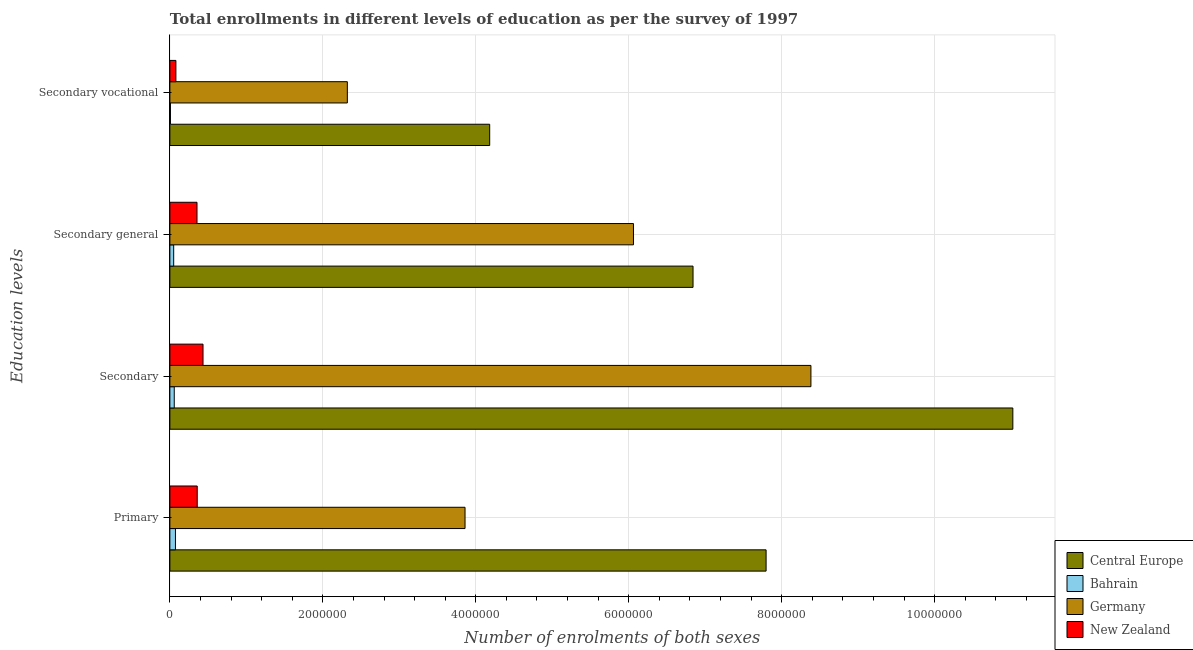How many different coloured bars are there?
Keep it short and to the point. 4. Are the number of bars per tick equal to the number of legend labels?
Offer a terse response. Yes. How many bars are there on the 3rd tick from the top?
Your answer should be very brief. 4. How many bars are there on the 4th tick from the bottom?
Your answer should be very brief. 4. What is the label of the 3rd group of bars from the top?
Your answer should be very brief. Secondary. What is the number of enrolments in secondary vocational education in Germany?
Provide a succinct answer. 2.32e+06. Across all countries, what is the maximum number of enrolments in secondary general education?
Your response must be concise. 6.84e+06. Across all countries, what is the minimum number of enrolments in primary education?
Your answer should be very brief. 7.29e+04. In which country was the number of enrolments in primary education maximum?
Give a very brief answer. Central Europe. In which country was the number of enrolments in secondary general education minimum?
Offer a very short reply. Bahrain. What is the total number of enrolments in secondary vocational education in the graph?
Offer a terse response. 6.59e+06. What is the difference between the number of enrolments in secondary vocational education in Germany and that in Bahrain?
Offer a very short reply. 2.31e+06. What is the difference between the number of enrolments in primary education in Bahrain and the number of enrolments in secondary education in New Zealand?
Your answer should be very brief. -3.60e+05. What is the average number of enrolments in primary education per country?
Offer a terse response. 3.02e+06. What is the difference between the number of enrolments in secondary education and number of enrolments in secondary vocational education in Bahrain?
Provide a succinct answer. 4.99e+04. What is the ratio of the number of enrolments in secondary vocational education in New Zealand to that in Germany?
Ensure brevity in your answer.  0.03. Is the difference between the number of enrolments in secondary vocational education in New Zealand and Central Europe greater than the difference between the number of enrolments in secondary education in New Zealand and Central Europe?
Provide a succinct answer. Yes. What is the difference between the highest and the second highest number of enrolments in primary education?
Your answer should be compact. 3.94e+06. What is the difference between the highest and the lowest number of enrolments in primary education?
Offer a very short reply. 7.72e+06. In how many countries, is the number of enrolments in secondary general education greater than the average number of enrolments in secondary general education taken over all countries?
Give a very brief answer. 2. What does the 4th bar from the top in Secondary general represents?
Provide a short and direct response. Central Europe. How many bars are there?
Make the answer very short. 16. Are all the bars in the graph horizontal?
Offer a terse response. Yes. How many countries are there in the graph?
Provide a succinct answer. 4. What is the difference between two consecutive major ticks on the X-axis?
Offer a terse response. 2.00e+06. How are the legend labels stacked?
Keep it short and to the point. Vertical. What is the title of the graph?
Keep it short and to the point. Total enrollments in different levels of education as per the survey of 1997. What is the label or title of the X-axis?
Make the answer very short. Number of enrolments of both sexes. What is the label or title of the Y-axis?
Offer a terse response. Education levels. What is the Number of enrolments of both sexes of Central Europe in Primary?
Offer a very short reply. 7.80e+06. What is the Number of enrolments of both sexes of Bahrain in Primary?
Your answer should be compact. 7.29e+04. What is the Number of enrolments of both sexes in Germany in Primary?
Provide a succinct answer. 3.86e+06. What is the Number of enrolments of both sexes in New Zealand in Primary?
Provide a short and direct response. 3.58e+05. What is the Number of enrolments of both sexes of Central Europe in Secondary?
Make the answer very short. 1.10e+07. What is the Number of enrolments of both sexes of Bahrain in Secondary?
Offer a very short reply. 5.72e+04. What is the Number of enrolments of both sexes in Germany in Secondary?
Provide a short and direct response. 8.38e+06. What is the Number of enrolments of both sexes in New Zealand in Secondary?
Provide a short and direct response. 4.33e+05. What is the Number of enrolments of both sexes of Central Europe in Secondary general?
Offer a very short reply. 6.84e+06. What is the Number of enrolments of both sexes of Bahrain in Secondary general?
Ensure brevity in your answer.  4.99e+04. What is the Number of enrolments of both sexes of Germany in Secondary general?
Your answer should be compact. 6.06e+06. What is the Number of enrolments of both sexes of New Zealand in Secondary general?
Your response must be concise. 3.55e+05. What is the Number of enrolments of both sexes of Central Europe in Secondary vocational?
Your response must be concise. 4.18e+06. What is the Number of enrolments of both sexes in Bahrain in Secondary vocational?
Provide a succinct answer. 7287. What is the Number of enrolments of both sexes in Germany in Secondary vocational?
Provide a short and direct response. 2.32e+06. What is the Number of enrolments of both sexes of New Zealand in Secondary vocational?
Keep it short and to the point. 7.86e+04. Across all Education levels, what is the maximum Number of enrolments of both sexes in Central Europe?
Keep it short and to the point. 1.10e+07. Across all Education levels, what is the maximum Number of enrolments of both sexes of Bahrain?
Your answer should be very brief. 7.29e+04. Across all Education levels, what is the maximum Number of enrolments of both sexes of Germany?
Make the answer very short. 8.38e+06. Across all Education levels, what is the maximum Number of enrolments of both sexes of New Zealand?
Provide a short and direct response. 4.33e+05. Across all Education levels, what is the minimum Number of enrolments of both sexes in Central Europe?
Provide a succinct answer. 4.18e+06. Across all Education levels, what is the minimum Number of enrolments of both sexes in Bahrain?
Give a very brief answer. 7287. Across all Education levels, what is the minimum Number of enrolments of both sexes of Germany?
Your answer should be compact. 2.32e+06. Across all Education levels, what is the minimum Number of enrolments of both sexes of New Zealand?
Provide a succinct answer. 7.86e+04. What is the total Number of enrolments of both sexes of Central Europe in the graph?
Give a very brief answer. 2.98e+07. What is the total Number of enrolments of both sexes of Bahrain in the graph?
Your response must be concise. 1.87e+05. What is the total Number of enrolments of both sexes in Germany in the graph?
Keep it short and to the point. 2.06e+07. What is the total Number of enrolments of both sexes in New Zealand in the graph?
Your answer should be very brief. 1.22e+06. What is the difference between the Number of enrolments of both sexes of Central Europe in Primary and that in Secondary?
Ensure brevity in your answer.  -3.23e+06. What is the difference between the Number of enrolments of both sexes of Bahrain in Primary and that in Secondary?
Make the answer very short. 1.57e+04. What is the difference between the Number of enrolments of both sexes of Germany in Primary and that in Secondary?
Provide a succinct answer. -4.52e+06. What is the difference between the Number of enrolments of both sexes of New Zealand in Primary and that in Secondary?
Your answer should be very brief. -7.58e+04. What is the difference between the Number of enrolments of both sexes in Central Europe in Primary and that in Secondary general?
Your answer should be very brief. 9.55e+05. What is the difference between the Number of enrolments of both sexes of Bahrain in Primary and that in Secondary general?
Keep it short and to the point. 2.30e+04. What is the difference between the Number of enrolments of both sexes in Germany in Primary and that in Secondary general?
Provide a short and direct response. -2.20e+06. What is the difference between the Number of enrolments of both sexes of New Zealand in Primary and that in Secondary general?
Your answer should be compact. 2862. What is the difference between the Number of enrolments of both sexes of Central Europe in Primary and that in Secondary vocational?
Keep it short and to the point. 3.61e+06. What is the difference between the Number of enrolments of both sexes of Bahrain in Primary and that in Secondary vocational?
Make the answer very short. 6.56e+04. What is the difference between the Number of enrolments of both sexes of Germany in Primary and that in Secondary vocational?
Your answer should be compact. 1.54e+06. What is the difference between the Number of enrolments of both sexes of New Zealand in Primary and that in Secondary vocational?
Offer a very short reply. 2.79e+05. What is the difference between the Number of enrolments of both sexes of Central Europe in Secondary and that in Secondary general?
Ensure brevity in your answer.  4.18e+06. What is the difference between the Number of enrolments of both sexes of Bahrain in Secondary and that in Secondary general?
Offer a very short reply. 7287. What is the difference between the Number of enrolments of both sexes of Germany in Secondary and that in Secondary general?
Ensure brevity in your answer.  2.32e+06. What is the difference between the Number of enrolments of both sexes in New Zealand in Secondary and that in Secondary general?
Keep it short and to the point. 7.86e+04. What is the difference between the Number of enrolments of both sexes of Central Europe in Secondary and that in Secondary vocational?
Provide a short and direct response. 6.84e+06. What is the difference between the Number of enrolments of both sexes of Bahrain in Secondary and that in Secondary vocational?
Give a very brief answer. 4.99e+04. What is the difference between the Number of enrolments of both sexes in Germany in Secondary and that in Secondary vocational?
Make the answer very short. 6.06e+06. What is the difference between the Number of enrolments of both sexes of New Zealand in Secondary and that in Secondary vocational?
Provide a succinct answer. 3.55e+05. What is the difference between the Number of enrolments of both sexes in Central Europe in Secondary general and that in Secondary vocational?
Provide a short and direct response. 2.66e+06. What is the difference between the Number of enrolments of both sexes of Bahrain in Secondary general and that in Secondary vocational?
Offer a very short reply. 4.26e+04. What is the difference between the Number of enrolments of both sexes of Germany in Secondary general and that in Secondary vocational?
Make the answer very short. 3.74e+06. What is the difference between the Number of enrolments of both sexes of New Zealand in Secondary general and that in Secondary vocational?
Your answer should be compact. 2.76e+05. What is the difference between the Number of enrolments of both sexes in Central Europe in Primary and the Number of enrolments of both sexes in Bahrain in Secondary?
Offer a terse response. 7.74e+06. What is the difference between the Number of enrolments of both sexes of Central Europe in Primary and the Number of enrolments of both sexes of Germany in Secondary?
Keep it short and to the point. -5.86e+05. What is the difference between the Number of enrolments of both sexes in Central Europe in Primary and the Number of enrolments of both sexes in New Zealand in Secondary?
Offer a very short reply. 7.36e+06. What is the difference between the Number of enrolments of both sexes in Bahrain in Primary and the Number of enrolments of both sexes in Germany in Secondary?
Provide a succinct answer. -8.31e+06. What is the difference between the Number of enrolments of both sexes of Bahrain in Primary and the Number of enrolments of both sexes of New Zealand in Secondary?
Provide a succinct answer. -3.60e+05. What is the difference between the Number of enrolments of both sexes in Germany in Primary and the Number of enrolments of both sexes in New Zealand in Secondary?
Your answer should be very brief. 3.43e+06. What is the difference between the Number of enrolments of both sexes of Central Europe in Primary and the Number of enrolments of both sexes of Bahrain in Secondary general?
Make the answer very short. 7.75e+06. What is the difference between the Number of enrolments of both sexes of Central Europe in Primary and the Number of enrolments of both sexes of Germany in Secondary general?
Ensure brevity in your answer.  1.73e+06. What is the difference between the Number of enrolments of both sexes in Central Europe in Primary and the Number of enrolments of both sexes in New Zealand in Secondary general?
Make the answer very short. 7.44e+06. What is the difference between the Number of enrolments of both sexes of Bahrain in Primary and the Number of enrolments of both sexes of Germany in Secondary general?
Give a very brief answer. -5.99e+06. What is the difference between the Number of enrolments of both sexes in Bahrain in Primary and the Number of enrolments of both sexes in New Zealand in Secondary general?
Keep it short and to the point. -2.82e+05. What is the difference between the Number of enrolments of both sexes of Germany in Primary and the Number of enrolments of both sexes of New Zealand in Secondary general?
Your answer should be very brief. 3.50e+06. What is the difference between the Number of enrolments of both sexes of Central Europe in Primary and the Number of enrolments of both sexes of Bahrain in Secondary vocational?
Provide a short and direct response. 7.79e+06. What is the difference between the Number of enrolments of both sexes in Central Europe in Primary and the Number of enrolments of both sexes in Germany in Secondary vocational?
Offer a terse response. 5.48e+06. What is the difference between the Number of enrolments of both sexes of Central Europe in Primary and the Number of enrolments of both sexes of New Zealand in Secondary vocational?
Make the answer very short. 7.72e+06. What is the difference between the Number of enrolments of both sexes of Bahrain in Primary and the Number of enrolments of both sexes of Germany in Secondary vocational?
Keep it short and to the point. -2.25e+06. What is the difference between the Number of enrolments of both sexes of Bahrain in Primary and the Number of enrolments of both sexes of New Zealand in Secondary vocational?
Provide a short and direct response. -5764. What is the difference between the Number of enrolments of both sexes of Germany in Primary and the Number of enrolments of both sexes of New Zealand in Secondary vocational?
Keep it short and to the point. 3.78e+06. What is the difference between the Number of enrolments of both sexes in Central Europe in Secondary and the Number of enrolments of both sexes in Bahrain in Secondary general?
Offer a terse response. 1.10e+07. What is the difference between the Number of enrolments of both sexes of Central Europe in Secondary and the Number of enrolments of both sexes of Germany in Secondary general?
Your answer should be very brief. 4.96e+06. What is the difference between the Number of enrolments of both sexes in Central Europe in Secondary and the Number of enrolments of both sexes in New Zealand in Secondary general?
Provide a succinct answer. 1.07e+07. What is the difference between the Number of enrolments of both sexes of Bahrain in Secondary and the Number of enrolments of both sexes of Germany in Secondary general?
Give a very brief answer. -6.00e+06. What is the difference between the Number of enrolments of both sexes of Bahrain in Secondary and the Number of enrolments of both sexes of New Zealand in Secondary general?
Your response must be concise. -2.98e+05. What is the difference between the Number of enrolments of both sexes in Germany in Secondary and the Number of enrolments of both sexes in New Zealand in Secondary general?
Your answer should be very brief. 8.03e+06. What is the difference between the Number of enrolments of both sexes in Central Europe in Secondary and the Number of enrolments of both sexes in Bahrain in Secondary vocational?
Offer a terse response. 1.10e+07. What is the difference between the Number of enrolments of both sexes in Central Europe in Secondary and the Number of enrolments of both sexes in Germany in Secondary vocational?
Offer a very short reply. 8.70e+06. What is the difference between the Number of enrolments of both sexes in Central Europe in Secondary and the Number of enrolments of both sexes in New Zealand in Secondary vocational?
Offer a terse response. 1.09e+07. What is the difference between the Number of enrolments of both sexes of Bahrain in Secondary and the Number of enrolments of both sexes of Germany in Secondary vocational?
Your response must be concise. -2.26e+06. What is the difference between the Number of enrolments of both sexes of Bahrain in Secondary and the Number of enrolments of both sexes of New Zealand in Secondary vocational?
Offer a terse response. -2.15e+04. What is the difference between the Number of enrolments of both sexes of Germany in Secondary and the Number of enrolments of both sexes of New Zealand in Secondary vocational?
Your answer should be very brief. 8.30e+06. What is the difference between the Number of enrolments of both sexes of Central Europe in Secondary general and the Number of enrolments of both sexes of Bahrain in Secondary vocational?
Your response must be concise. 6.83e+06. What is the difference between the Number of enrolments of both sexes in Central Europe in Secondary general and the Number of enrolments of both sexes in Germany in Secondary vocational?
Provide a succinct answer. 4.52e+06. What is the difference between the Number of enrolments of both sexes of Central Europe in Secondary general and the Number of enrolments of both sexes of New Zealand in Secondary vocational?
Your response must be concise. 6.76e+06. What is the difference between the Number of enrolments of both sexes in Bahrain in Secondary general and the Number of enrolments of both sexes in Germany in Secondary vocational?
Offer a very short reply. -2.27e+06. What is the difference between the Number of enrolments of both sexes in Bahrain in Secondary general and the Number of enrolments of both sexes in New Zealand in Secondary vocational?
Your response must be concise. -2.87e+04. What is the difference between the Number of enrolments of both sexes in Germany in Secondary general and the Number of enrolments of both sexes in New Zealand in Secondary vocational?
Provide a succinct answer. 5.98e+06. What is the average Number of enrolments of both sexes in Central Europe per Education levels?
Offer a very short reply. 7.46e+06. What is the average Number of enrolments of both sexes in Bahrain per Education levels?
Offer a very short reply. 4.68e+04. What is the average Number of enrolments of both sexes of Germany per Education levels?
Offer a very short reply. 5.16e+06. What is the average Number of enrolments of both sexes in New Zealand per Education levels?
Give a very brief answer. 3.06e+05. What is the difference between the Number of enrolments of both sexes in Central Europe and Number of enrolments of both sexes in Bahrain in Primary?
Your answer should be very brief. 7.72e+06. What is the difference between the Number of enrolments of both sexes in Central Europe and Number of enrolments of both sexes in Germany in Primary?
Ensure brevity in your answer.  3.94e+06. What is the difference between the Number of enrolments of both sexes of Central Europe and Number of enrolments of both sexes of New Zealand in Primary?
Keep it short and to the point. 7.44e+06. What is the difference between the Number of enrolments of both sexes in Bahrain and Number of enrolments of both sexes in Germany in Primary?
Ensure brevity in your answer.  -3.79e+06. What is the difference between the Number of enrolments of both sexes in Bahrain and Number of enrolments of both sexes in New Zealand in Primary?
Make the answer very short. -2.85e+05. What is the difference between the Number of enrolments of both sexes in Germany and Number of enrolments of both sexes in New Zealand in Primary?
Your answer should be very brief. 3.50e+06. What is the difference between the Number of enrolments of both sexes of Central Europe and Number of enrolments of both sexes of Bahrain in Secondary?
Your answer should be compact. 1.10e+07. What is the difference between the Number of enrolments of both sexes in Central Europe and Number of enrolments of both sexes in Germany in Secondary?
Your response must be concise. 2.64e+06. What is the difference between the Number of enrolments of both sexes in Central Europe and Number of enrolments of both sexes in New Zealand in Secondary?
Provide a short and direct response. 1.06e+07. What is the difference between the Number of enrolments of both sexes of Bahrain and Number of enrolments of both sexes of Germany in Secondary?
Your response must be concise. -8.33e+06. What is the difference between the Number of enrolments of both sexes in Bahrain and Number of enrolments of both sexes in New Zealand in Secondary?
Offer a very short reply. -3.76e+05. What is the difference between the Number of enrolments of both sexes of Germany and Number of enrolments of both sexes of New Zealand in Secondary?
Give a very brief answer. 7.95e+06. What is the difference between the Number of enrolments of both sexes in Central Europe and Number of enrolments of both sexes in Bahrain in Secondary general?
Your answer should be compact. 6.79e+06. What is the difference between the Number of enrolments of both sexes in Central Europe and Number of enrolments of both sexes in Germany in Secondary general?
Your answer should be compact. 7.79e+05. What is the difference between the Number of enrolments of both sexes of Central Europe and Number of enrolments of both sexes of New Zealand in Secondary general?
Give a very brief answer. 6.49e+06. What is the difference between the Number of enrolments of both sexes in Bahrain and Number of enrolments of both sexes in Germany in Secondary general?
Provide a short and direct response. -6.01e+06. What is the difference between the Number of enrolments of both sexes in Bahrain and Number of enrolments of both sexes in New Zealand in Secondary general?
Your answer should be compact. -3.05e+05. What is the difference between the Number of enrolments of both sexes in Germany and Number of enrolments of both sexes in New Zealand in Secondary general?
Make the answer very short. 5.71e+06. What is the difference between the Number of enrolments of both sexes in Central Europe and Number of enrolments of both sexes in Bahrain in Secondary vocational?
Offer a very short reply. 4.17e+06. What is the difference between the Number of enrolments of both sexes in Central Europe and Number of enrolments of both sexes in Germany in Secondary vocational?
Provide a succinct answer. 1.86e+06. What is the difference between the Number of enrolments of both sexes of Central Europe and Number of enrolments of both sexes of New Zealand in Secondary vocational?
Your answer should be very brief. 4.10e+06. What is the difference between the Number of enrolments of both sexes of Bahrain and Number of enrolments of both sexes of Germany in Secondary vocational?
Provide a short and direct response. -2.31e+06. What is the difference between the Number of enrolments of both sexes of Bahrain and Number of enrolments of both sexes of New Zealand in Secondary vocational?
Provide a succinct answer. -7.14e+04. What is the difference between the Number of enrolments of both sexes of Germany and Number of enrolments of both sexes of New Zealand in Secondary vocational?
Provide a short and direct response. 2.24e+06. What is the ratio of the Number of enrolments of both sexes in Central Europe in Primary to that in Secondary?
Your answer should be very brief. 0.71. What is the ratio of the Number of enrolments of both sexes of Bahrain in Primary to that in Secondary?
Give a very brief answer. 1.27. What is the ratio of the Number of enrolments of both sexes of Germany in Primary to that in Secondary?
Your answer should be very brief. 0.46. What is the ratio of the Number of enrolments of both sexes in New Zealand in Primary to that in Secondary?
Provide a succinct answer. 0.83. What is the ratio of the Number of enrolments of both sexes of Central Europe in Primary to that in Secondary general?
Keep it short and to the point. 1.14. What is the ratio of the Number of enrolments of both sexes in Bahrain in Primary to that in Secondary general?
Your answer should be compact. 1.46. What is the ratio of the Number of enrolments of both sexes of Germany in Primary to that in Secondary general?
Your answer should be compact. 0.64. What is the ratio of the Number of enrolments of both sexes of New Zealand in Primary to that in Secondary general?
Your answer should be compact. 1.01. What is the ratio of the Number of enrolments of both sexes of Central Europe in Primary to that in Secondary vocational?
Provide a short and direct response. 1.86. What is the ratio of the Number of enrolments of both sexes in Bahrain in Primary to that in Secondary vocational?
Offer a very short reply. 10. What is the ratio of the Number of enrolments of both sexes of Germany in Primary to that in Secondary vocational?
Your answer should be very brief. 1.66. What is the ratio of the Number of enrolments of both sexes in New Zealand in Primary to that in Secondary vocational?
Give a very brief answer. 4.55. What is the ratio of the Number of enrolments of both sexes of Central Europe in Secondary to that in Secondary general?
Offer a very short reply. 1.61. What is the ratio of the Number of enrolments of both sexes in Bahrain in Secondary to that in Secondary general?
Ensure brevity in your answer.  1.15. What is the ratio of the Number of enrolments of both sexes of Germany in Secondary to that in Secondary general?
Give a very brief answer. 1.38. What is the ratio of the Number of enrolments of both sexes in New Zealand in Secondary to that in Secondary general?
Provide a succinct answer. 1.22. What is the ratio of the Number of enrolments of both sexes in Central Europe in Secondary to that in Secondary vocational?
Your response must be concise. 2.64. What is the ratio of the Number of enrolments of both sexes of Bahrain in Secondary to that in Secondary vocational?
Your answer should be very brief. 7.85. What is the ratio of the Number of enrolments of both sexes of Germany in Secondary to that in Secondary vocational?
Make the answer very short. 3.61. What is the ratio of the Number of enrolments of both sexes of New Zealand in Secondary to that in Secondary vocational?
Give a very brief answer. 5.51. What is the ratio of the Number of enrolments of both sexes in Central Europe in Secondary general to that in Secondary vocational?
Your answer should be very brief. 1.64. What is the ratio of the Number of enrolments of both sexes in Bahrain in Secondary general to that in Secondary vocational?
Provide a succinct answer. 6.85. What is the ratio of the Number of enrolments of both sexes of Germany in Secondary general to that in Secondary vocational?
Provide a short and direct response. 2.61. What is the ratio of the Number of enrolments of both sexes of New Zealand in Secondary general to that in Secondary vocational?
Give a very brief answer. 4.51. What is the difference between the highest and the second highest Number of enrolments of both sexes in Central Europe?
Make the answer very short. 3.23e+06. What is the difference between the highest and the second highest Number of enrolments of both sexes of Bahrain?
Your answer should be very brief. 1.57e+04. What is the difference between the highest and the second highest Number of enrolments of both sexes in Germany?
Provide a short and direct response. 2.32e+06. What is the difference between the highest and the second highest Number of enrolments of both sexes in New Zealand?
Offer a terse response. 7.58e+04. What is the difference between the highest and the lowest Number of enrolments of both sexes of Central Europe?
Provide a short and direct response. 6.84e+06. What is the difference between the highest and the lowest Number of enrolments of both sexes of Bahrain?
Provide a succinct answer. 6.56e+04. What is the difference between the highest and the lowest Number of enrolments of both sexes of Germany?
Offer a very short reply. 6.06e+06. What is the difference between the highest and the lowest Number of enrolments of both sexes in New Zealand?
Give a very brief answer. 3.55e+05. 